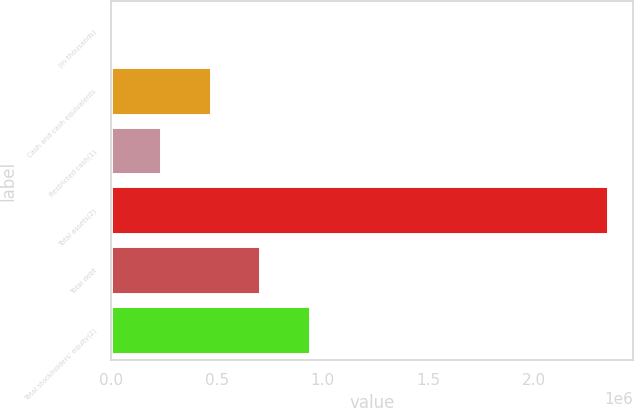Convert chart to OTSL. <chart><loc_0><loc_0><loc_500><loc_500><bar_chart><fcel>(in thousands)<fcel>Cash and cash equivalents<fcel>Restricted cash(1)<fcel>Total assets(2)<fcel>Total debt<fcel>Total stockholders' equity(2)<nl><fcel>2011<fcel>471443<fcel>236727<fcel>2.34917e+06<fcel>706158<fcel>940874<nl></chart> 